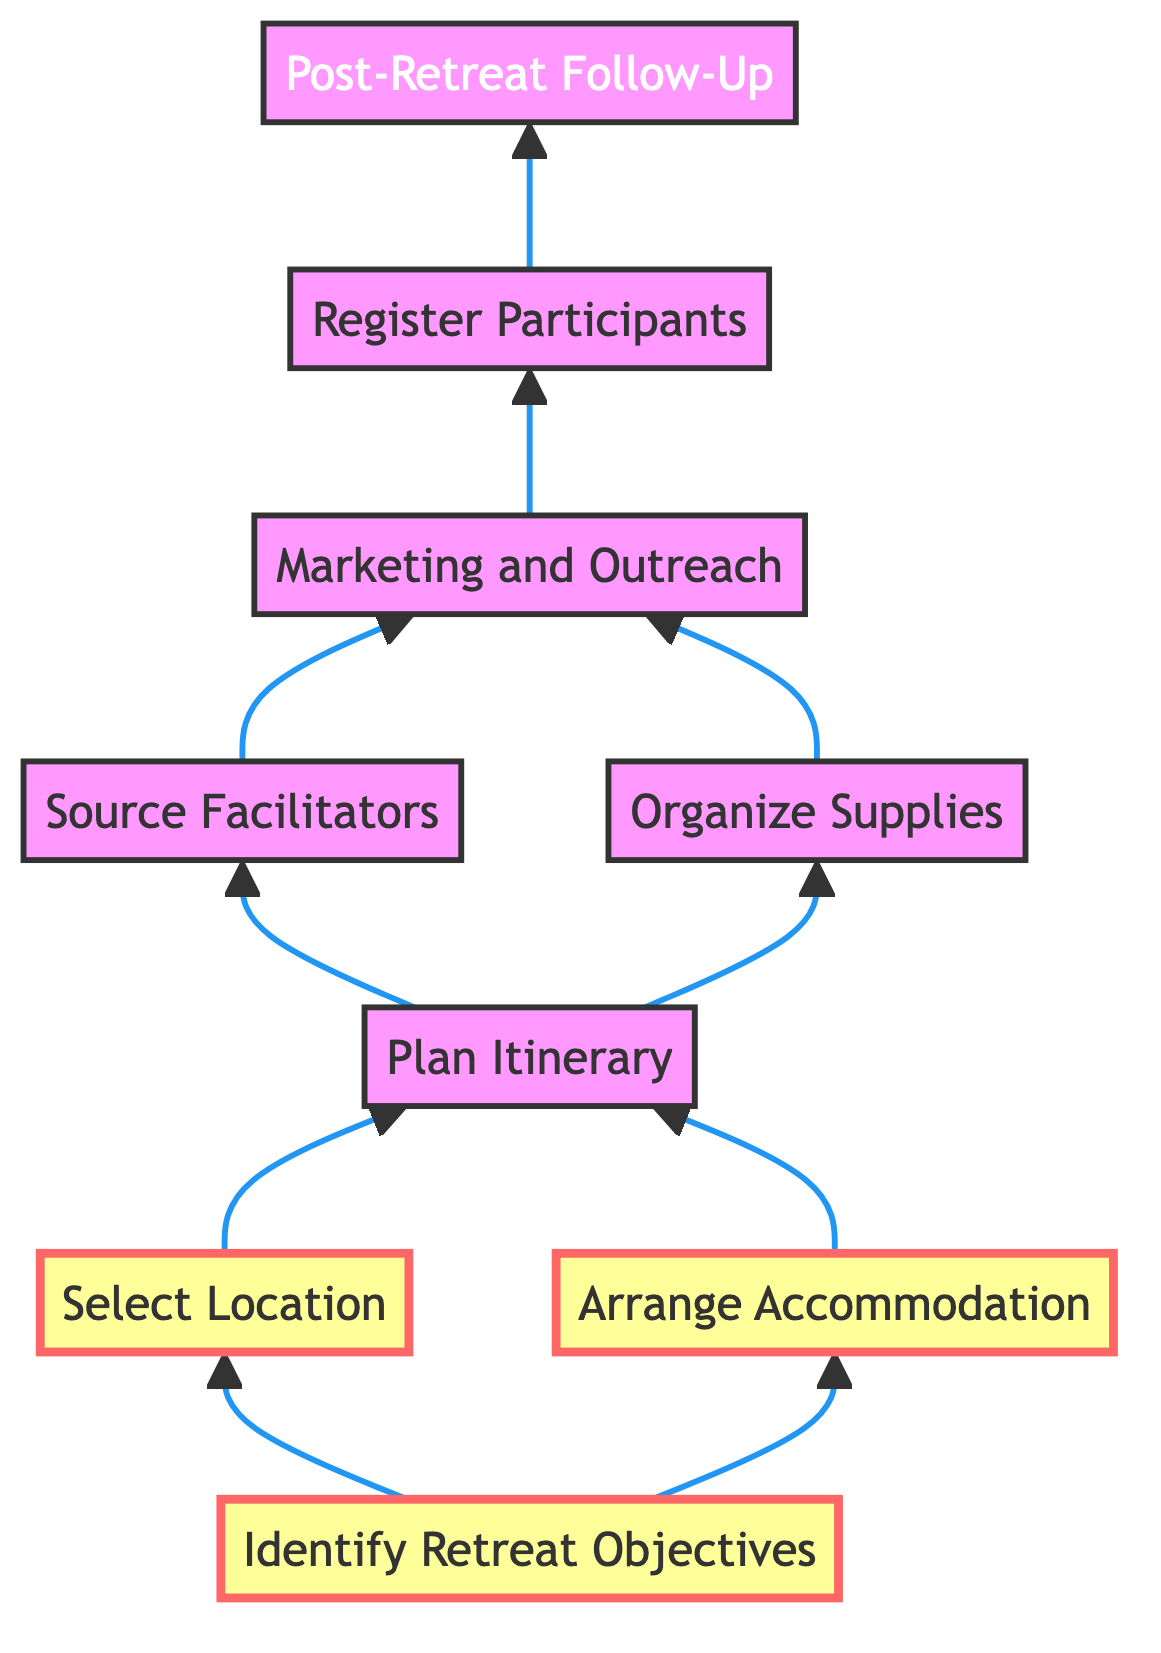What is the first step in the retreat planning process? The diagram indicates that the first step in the flow is "Identify Retreat Objectives," which is the starting point before any further action can be taken.
Answer: Identify Retreat Objectives How many main activities are involved before registering participants? The diagram presents a sequence of steps leading up to registration. Starting from identifying objectives to arranging accommodations, planning itineraries, sourcing facilitators, and organizing supplies, there are five main activities before the "Register Participants" step.
Answer: Five Which step comes immediately after planning the itinerary? According to the diagram, after "Plan Itinerary," the next steps are "Source Facilitators" and "Organize Supplies." This means both these steps follow immediately after planning.
Answer: Source Facilitators, Organize Supplies What determines the selection of a location for the retreat? The diagram states that the selection of a location is directly influenced by the retreat objectives established in the first step. Without identifying these objectives, a suitable location cannot be effectively chosen.
Answer: Identify Retreat Objectives What is the final step of the planning process? Looking at the diagram, the last step after all previous activities, including registration, is "Post-Retreat Follow-Up," meaning this is the concluding action taken.
Answer: Post-Retreat Follow-Up Which steps are performed concurrently before marketing and outreach? The steps "Source Facilitators" and "Organize Supplies" can be performed concurrently as indicated by the diagram, which shows them branching out from "Plan Itinerary" and leading into "Marketing and Outreach."
Answer: Source Facilitators, Organize Supplies How is participant feedback handled post-retreat? The diagram specifies that feedback is collected during the "Post-Retreat Follow-Up" step by reaching out to participants for comments and insights after the retreat concludes.
Answer: Post-Retreat Follow-Up What relationship exists between "Arrange Accommodation" and "Plan Itinerary"? The diagram indicates a direct connection between "Arrange Accommodation" and "Plan Itinerary." Both of these steps lead to the "Plan Itinerary," meaning accommodation arrangements contribute to the overall itinerary planning.
Answer: Both lead to Plan Itinerary What is a prerequisite for engaging facilitators? To engage facilitators, the diagram shows that one must first complete the "Plan Itinerary" step, as the itinerary's structure determines the type of facilitators needed.
Answer: Plan Itinerary 